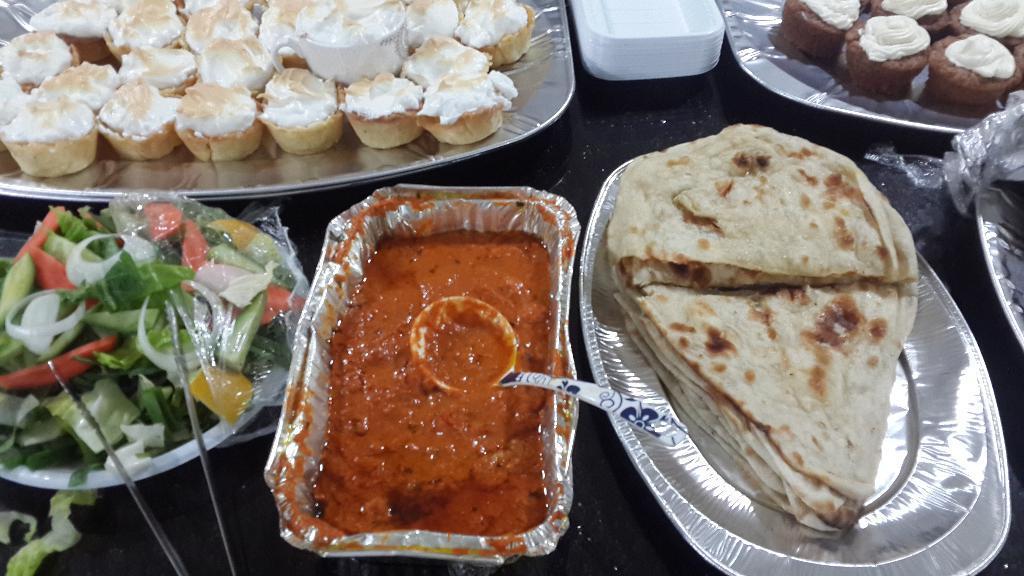Could you give a brief overview of what you see in this image? In this picture there is a table, on the table there are plates and food items. The food items are cupcakes, vegetables. parathas and curries. 